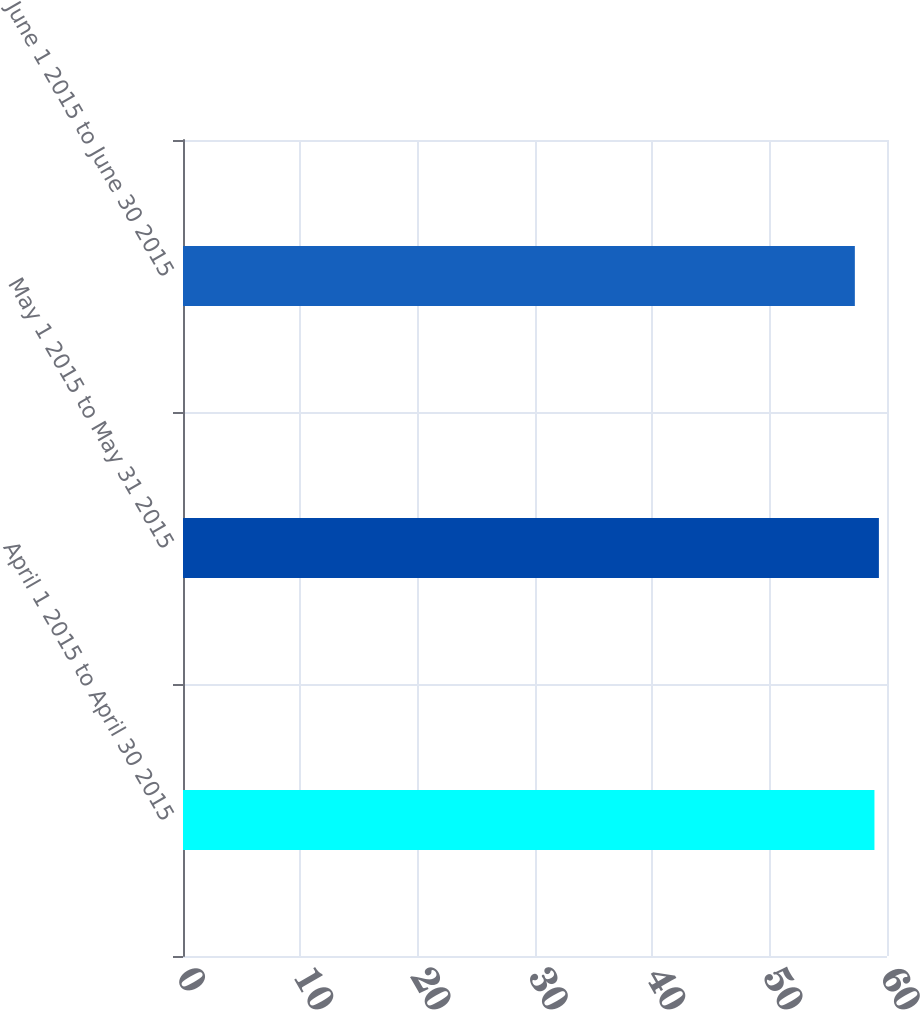Convert chart to OTSL. <chart><loc_0><loc_0><loc_500><loc_500><bar_chart><fcel>April 1 2015 to April 30 2015<fcel>May 1 2015 to May 31 2015<fcel>June 1 2015 to June 30 2015<nl><fcel>58.93<fcel>59.31<fcel>57.26<nl></chart> 